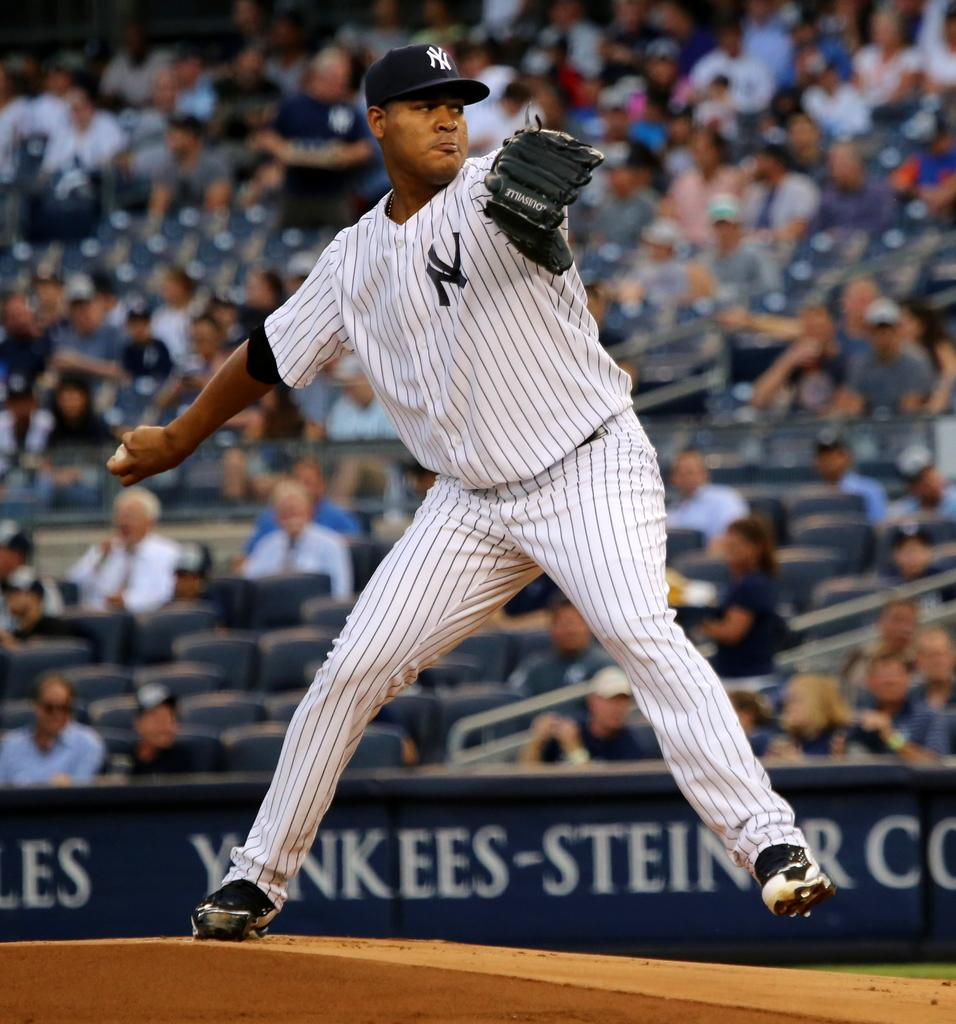Provide a one-sentence caption for the provided image. pitcher with ny on jersey and cap getting ready to throw baseball. 